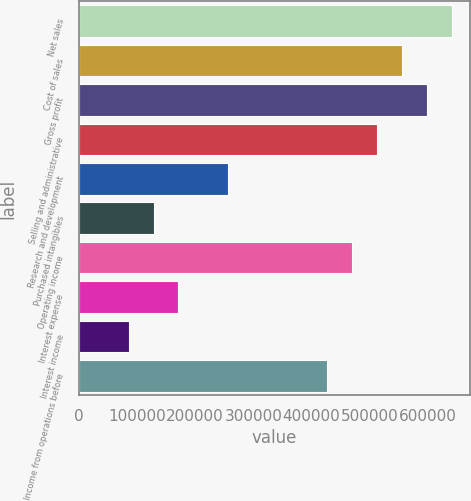<chart> <loc_0><loc_0><loc_500><loc_500><bar_chart><fcel>Net sales<fcel>Cost of sales<fcel>Gross profit<fcel>Selling and administrative<fcel>Research and development<fcel>Purchased intangibles<fcel>Operating income<fcel>Interest expense<fcel>Interest income<fcel>Income from operations before<nl><fcel>641404<fcel>555884<fcel>598644<fcel>513123<fcel>256562<fcel>128281<fcel>470363<fcel>171042<fcel>85521.2<fcel>427603<nl></chart> 